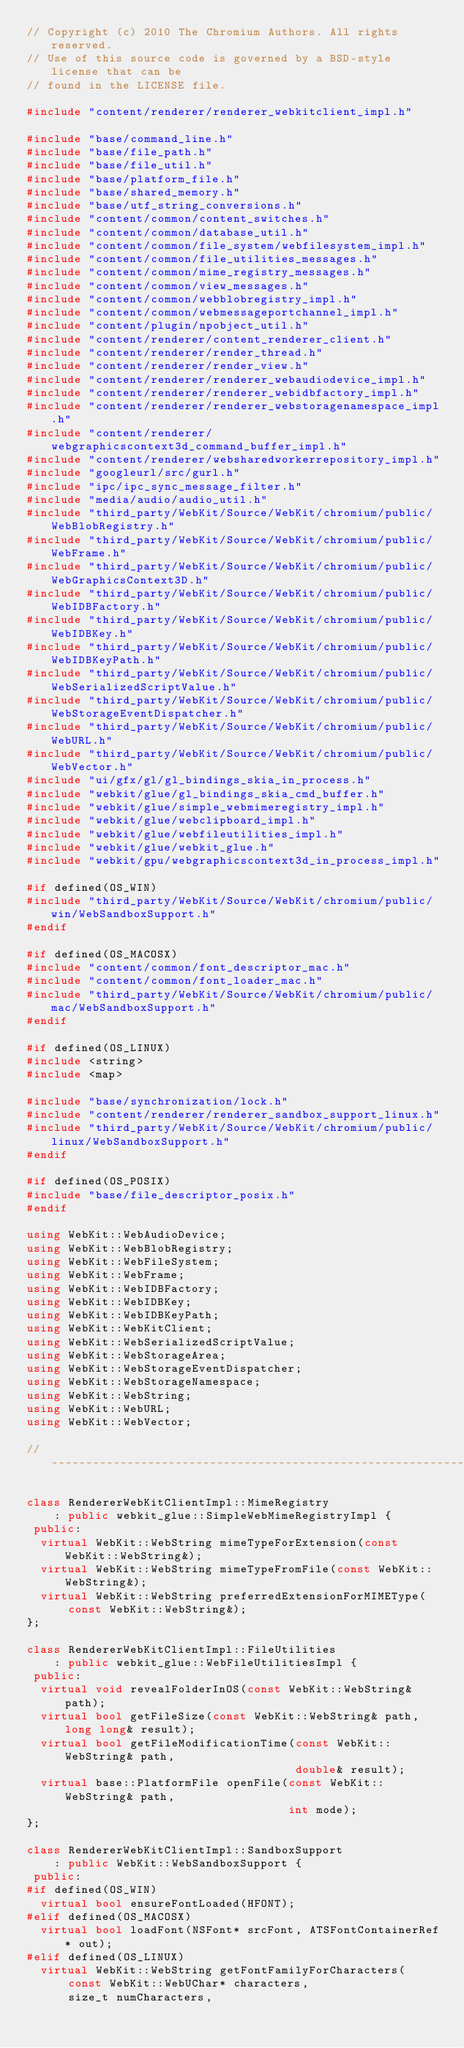Convert code to text. <code><loc_0><loc_0><loc_500><loc_500><_C++_>// Copyright (c) 2010 The Chromium Authors. All rights reserved.
// Use of this source code is governed by a BSD-style license that can be
// found in the LICENSE file.

#include "content/renderer/renderer_webkitclient_impl.h"

#include "base/command_line.h"
#include "base/file_path.h"
#include "base/file_util.h"
#include "base/platform_file.h"
#include "base/shared_memory.h"
#include "base/utf_string_conversions.h"
#include "content/common/content_switches.h"
#include "content/common/database_util.h"
#include "content/common/file_system/webfilesystem_impl.h"
#include "content/common/file_utilities_messages.h"
#include "content/common/mime_registry_messages.h"
#include "content/common/view_messages.h"
#include "content/common/webblobregistry_impl.h"
#include "content/common/webmessageportchannel_impl.h"
#include "content/plugin/npobject_util.h"
#include "content/renderer/content_renderer_client.h"
#include "content/renderer/render_thread.h"
#include "content/renderer/render_view.h"
#include "content/renderer/renderer_webaudiodevice_impl.h"
#include "content/renderer/renderer_webidbfactory_impl.h"
#include "content/renderer/renderer_webstoragenamespace_impl.h"
#include "content/renderer/webgraphicscontext3d_command_buffer_impl.h"
#include "content/renderer/websharedworkerrepository_impl.h"
#include "googleurl/src/gurl.h"
#include "ipc/ipc_sync_message_filter.h"
#include "media/audio/audio_util.h"
#include "third_party/WebKit/Source/WebKit/chromium/public/WebBlobRegistry.h"
#include "third_party/WebKit/Source/WebKit/chromium/public/WebFrame.h"
#include "third_party/WebKit/Source/WebKit/chromium/public/WebGraphicsContext3D.h"
#include "third_party/WebKit/Source/WebKit/chromium/public/WebIDBFactory.h"
#include "third_party/WebKit/Source/WebKit/chromium/public/WebIDBKey.h"
#include "third_party/WebKit/Source/WebKit/chromium/public/WebIDBKeyPath.h"
#include "third_party/WebKit/Source/WebKit/chromium/public/WebSerializedScriptValue.h"
#include "third_party/WebKit/Source/WebKit/chromium/public/WebStorageEventDispatcher.h"
#include "third_party/WebKit/Source/WebKit/chromium/public/WebURL.h"
#include "third_party/WebKit/Source/WebKit/chromium/public/WebVector.h"
#include "ui/gfx/gl/gl_bindings_skia_in_process.h"
#include "webkit/glue/gl_bindings_skia_cmd_buffer.h"
#include "webkit/glue/simple_webmimeregistry_impl.h"
#include "webkit/glue/webclipboard_impl.h"
#include "webkit/glue/webfileutilities_impl.h"
#include "webkit/glue/webkit_glue.h"
#include "webkit/gpu/webgraphicscontext3d_in_process_impl.h"

#if defined(OS_WIN)
#include "third_party/WebKit/Source/WebKit/chromium/public/win/WebSandboxSupport.h"
#endif

#if defined(OS_MACOSX)
#include "content/common/font_descriptor_mac.h"
#include "content/common/font_loader_mac.h"
#include "third_party/WebKit/Source/WebKit/chromium/public/mac/WebSandboxSupport.h"
#endif

#if defined(OS_LINUX)
#include <string>
#include <map>

#include "base/synchronization/lock.h"
#include "content/renderer/renderer_sandbox_support_linux.h"
#include "third_party/WebKit/Source/WebKit/chromium/public/linux/WebSandboxSupport.h"
#endif

#if defined(OS_POSIX)
#include "base/file_descriptor_posix.h"
#endif

using WebKit::WebAudioDevice;
using WebKit::WebBlobRegistry;
using WebKit::WebFileSystem;
using WebKit::WebFrame;
using WebKit::WebIDBFactory;
using WebKit::WebIDBKey;
using WebKit::WebIDBKeyPath;
using WebKit::WebKitClient;
using WebKit::WebSerializedScriptValue;
using WebKit::WebStorageArea;
using WebKit::WebStorageEventDispatcher;
using WebKit::WebStorageNamespace;
using WebKit::WebString;
using WebKit::WebURL;
using WebKit::WebVector;

//------------------------------------------------------------------------------

class RendererWebKitClientImpl::MimeRegistry
    : public webkit_glue::SimpleWebMimeRegistryImpl {
 public:
  virtual WebKit::WebString mimeTypeForExtension(const WebKit::WebString&);
  virtual WebKit::WebString mimeTypeFromFile(const WebKit::WebString&);
  virtual WebKit::WebString preferredExtensionForMIMEType(
      const WebKit::WebString&);
};

class RendererWebKitClientImpl::FileUtilities
    : public webkit_glue::WebFileUtilitiesImpl {
 public:
  virtual void revealFolderInOS(const WebKit::WebString& path);
  virtual bool getFileSize(const WebKit::WebString& path, long long& result);
  virtual bool getFileModificationTime(const WebKit::WebString& path,
                                       double& result);
  virtual base::PlatformFile openFile(const WebKit::WebString& path,
                                      int mode);
};

class RendererWebKitClientImpl::SandboxSupport
    : public WebKit::WebSandboxSupport {
 public:
#if defined(OS_WIN)
  virtual bool ensureFontLoaded(HFONT);
#elif defined(OS_MACOSX)
  virtual bool loadFont(NSFont* srcFont, ATSFontContainerRef* out);
#elif defined(OS_LINUX)
  virtual WebKit::WebString getFontFamilyForCharacters(
      const WebKit::WebUChar* characters,
      size_t numCharacters,</code> 